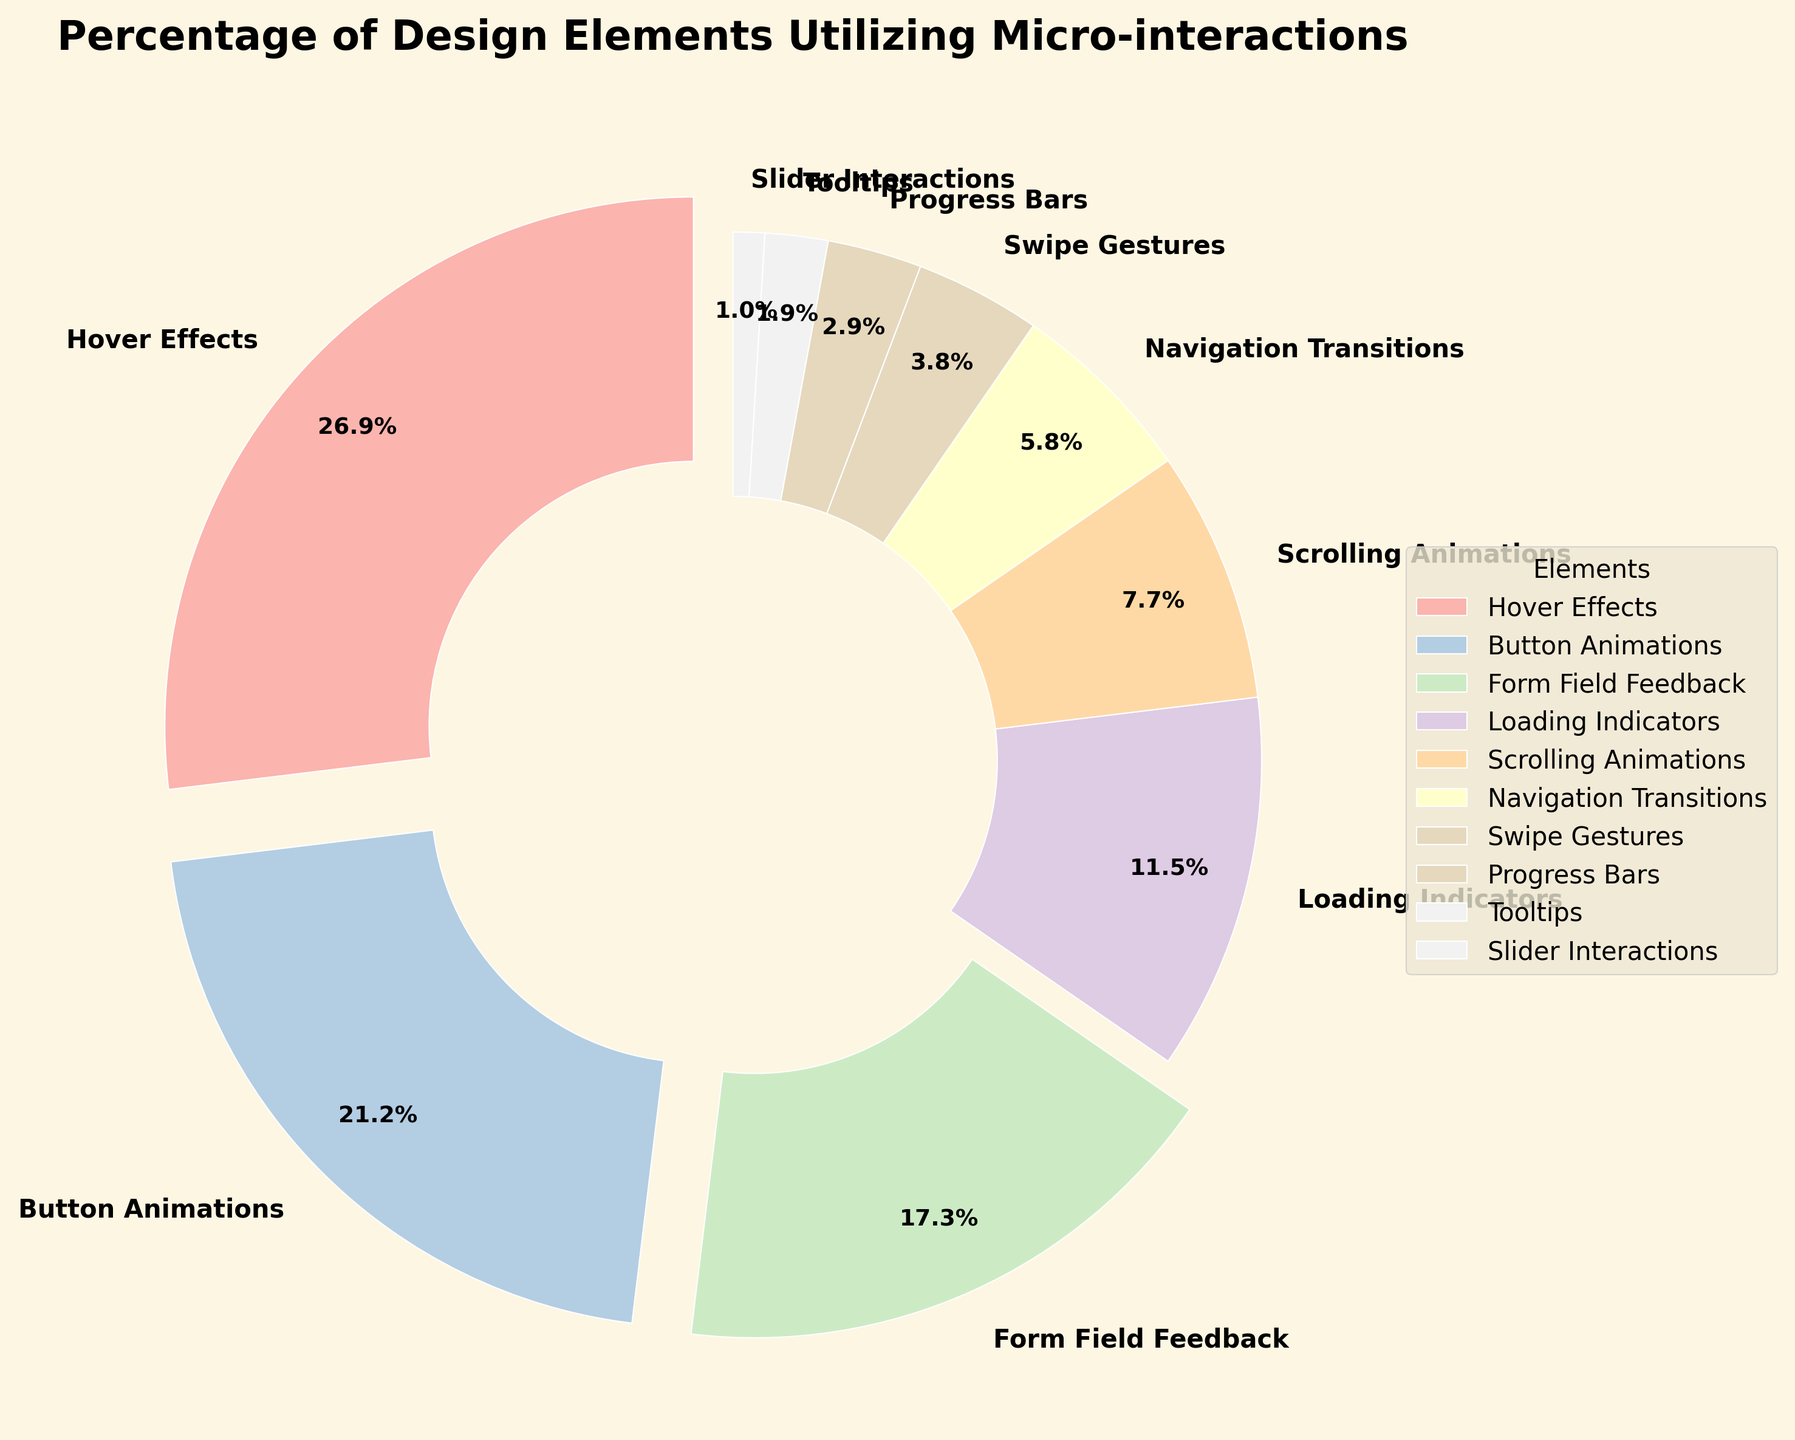Which design element has the highest percentage of utilization in micro-interactions? The section of the pie chart that represents "Hover Effects" appears the largest with a percentage value of 28%. This indicates it has the highest percentage.
Answer: Hover Effects What is the combined percentage of "Form Field Feedback" and "Loading Indicators"? Add the percentages for "Form Field Feedback" (18%) and "Loading Indicators" (12%). The combined percentage is 18% + 12% = 30%.
Answer: 30% Which element has a lower percentage, "Swipe Gestures" or "Slider Interactions"? The pie chart shows that "Slider Interactions" has a smaller section than "Swipe Gestures". With percentages of 1% and 4% respectively, "Slider Interactions" has the lower percentage.
Answer: Slider Interactions What percentage of the design elements have micro-interactions with less than 10% utilization each? Sum the percentages of elements with less than 10%: Scrolling Animations (8%), Navigation Transitions (6%), Swipe Gestures (4%), Progress Bars (3%), Tooltips (2%), Slider Interactions (1%). 8% + 6% + 4% + 3% + 2% + 1% = 24%.
Answer: 24% How does the percentage of "Hover Effects" compare to the sum of "Button Animations" and "Loading Indicators"? "Hover Effects" has a percentage of 28%. Adding the percentages of "Button Animations" (22%) and "Loading Indicators" (12%) gives 22% + 12% = 34%. Therefore, "Hover Effects" (28%) is less than the sum of "Button Animations" and "Loading Indicators" (34%).
Answer: Less than Which colors represent the design elements with the highest and lowest utilization percentages, respectively? The pie chart uses colors from the Pastel1 colormap. "Hover Effects" (highest, 28%) is likely represented by the first color, and "Slider Interactions" (lowest, 1%) by the last color. Without the actual color key, the exact colors cannot be named but are distinguishable by their position and size.
Answer: First color, last color What is the percentage difference between "Button Animations" and "Scrolling Animations"? Subtract the percentage of "Scrolling Animations" (8%) from "Button Animations" (22%). The difference is 22% - 8% = 14%.
Answer: 14% If the sum of "Tooltips" and "Progress Bars" percentages was doubled, how would it compare to "Hover Effects"? Sum "Tooltips" (2%) and "Progress Bars" (3%) for a total of 5%. Doubling it gives 5% x 2 = 10%, which is less than "Hover Effects" (28%).
Answer: Less than 